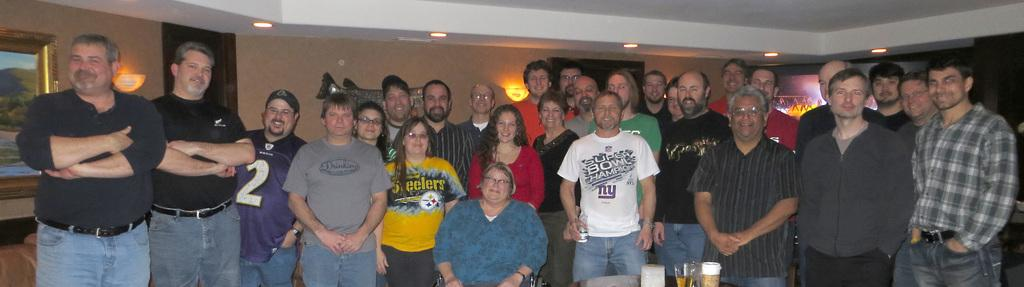How many people are in the image? There is a group of people in the image. What is present on the table in the image? There are glasses on the table. What can be seen in the background of the image? There is a wall, a ceiling, lights, a frame, a screen, and other objects in the background of the image. Can you see any baby animals in the image? There are no baby animals present in the image. Is there a window visible in the image? There is no window visible in the image. 